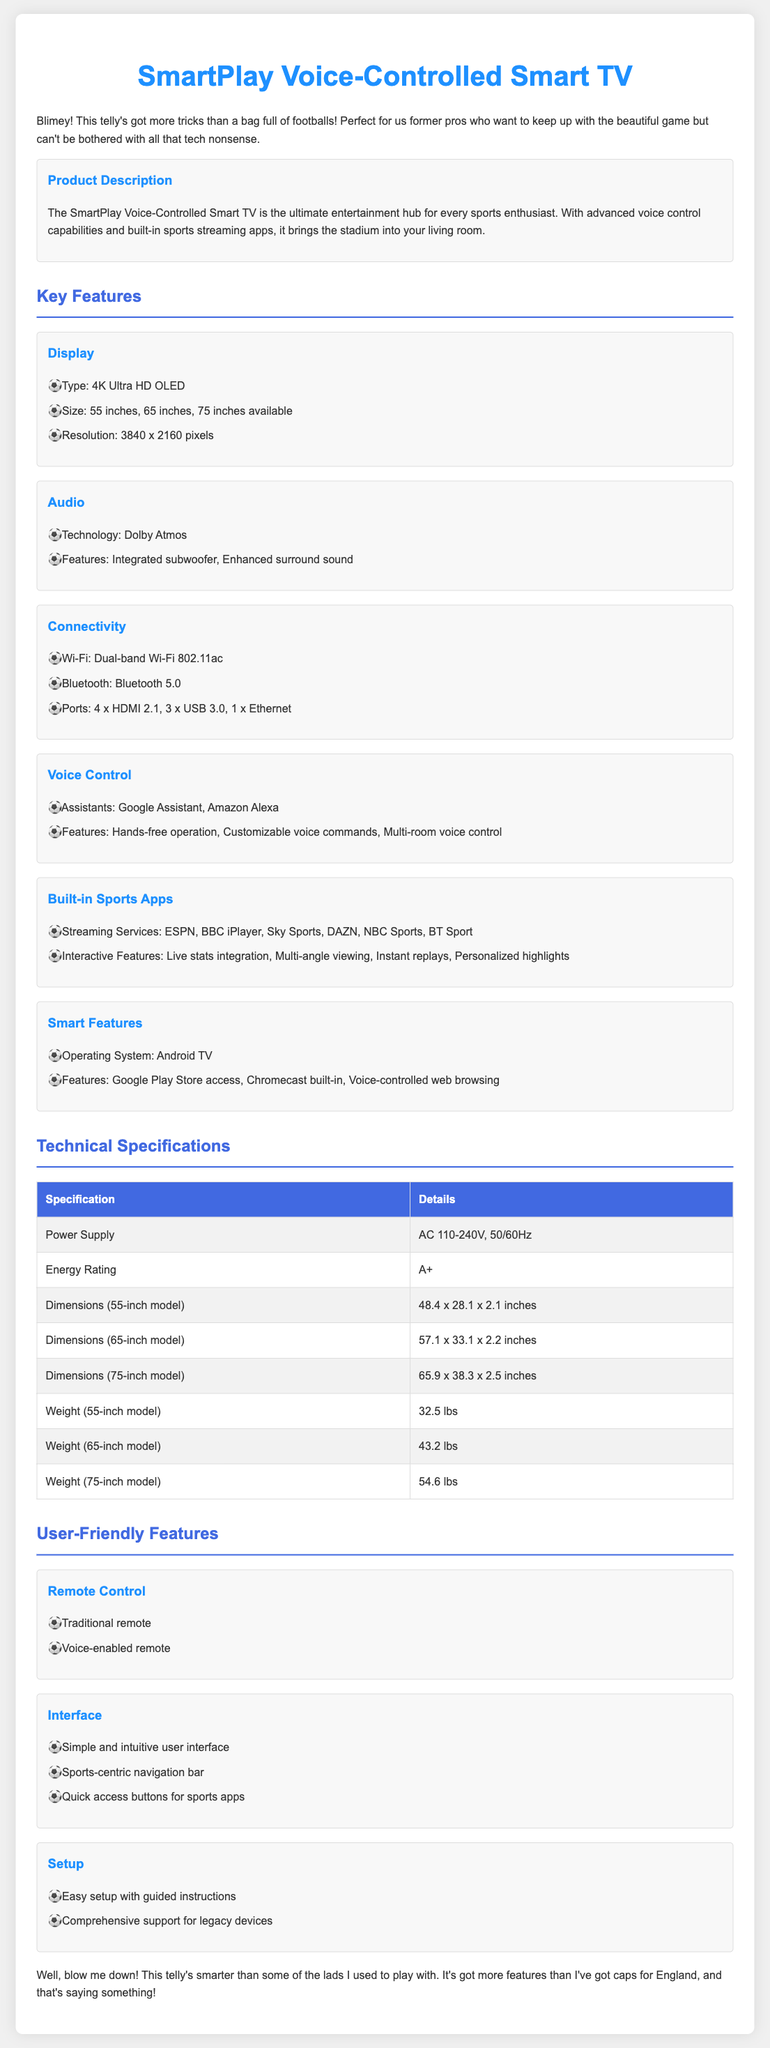what is the size options available for the SmartPlay TV? The document lists the sizes available for the SmartPlay TV as 55 inches, 65 inches, and 75 inches.
Answer: 55 inches, 65 inches, 75 inches what type of audio technology does the SmartPlay TV use? The document specifies that the SmartPlay TV features Dolby Atmos as its audio technology.
Answer: Dolby Atmos which voice assistants are integrated into the SmartPlay TV? The document mentions that Google Assistant and Amazon Alexa are the integrated voice assistants.
Answer: Google Assistant, Amazon Alexa how many HDMI ports does the SmartPlay TV have? The document states that the SmartPlay TV is equipped with 4 HDMI 2.1 ports.
Answer: 4 x HDMI 2.1 what is the energy rating of the SmartPlay TV? The document indicates that the energy rating of the SmartPlay TV is A+.
Answer: A+ what is the weight of the 65-inch model? The document provides the weight of the 65-inch model as 43.2 lbs.
Answer: 43.2 lbs what feature enhances the SmartPlay TV for sports enthusiasts? The document highlights built-in sports streaming apps as a feature that enhances the TV for sports enthusiasts.
Answer: Built-in sports streaming apps what type of display does the SmartPlay TV have? The document specifies that the display type is 4K Ultra HD OLED.
Answer: 4K Ultra HD OLED what is one of the user-friendly features mentioned in the document? The document lists a simple and intuitive user interface as a user-friendly feature.
Answer: Simple and intuitive user interface 